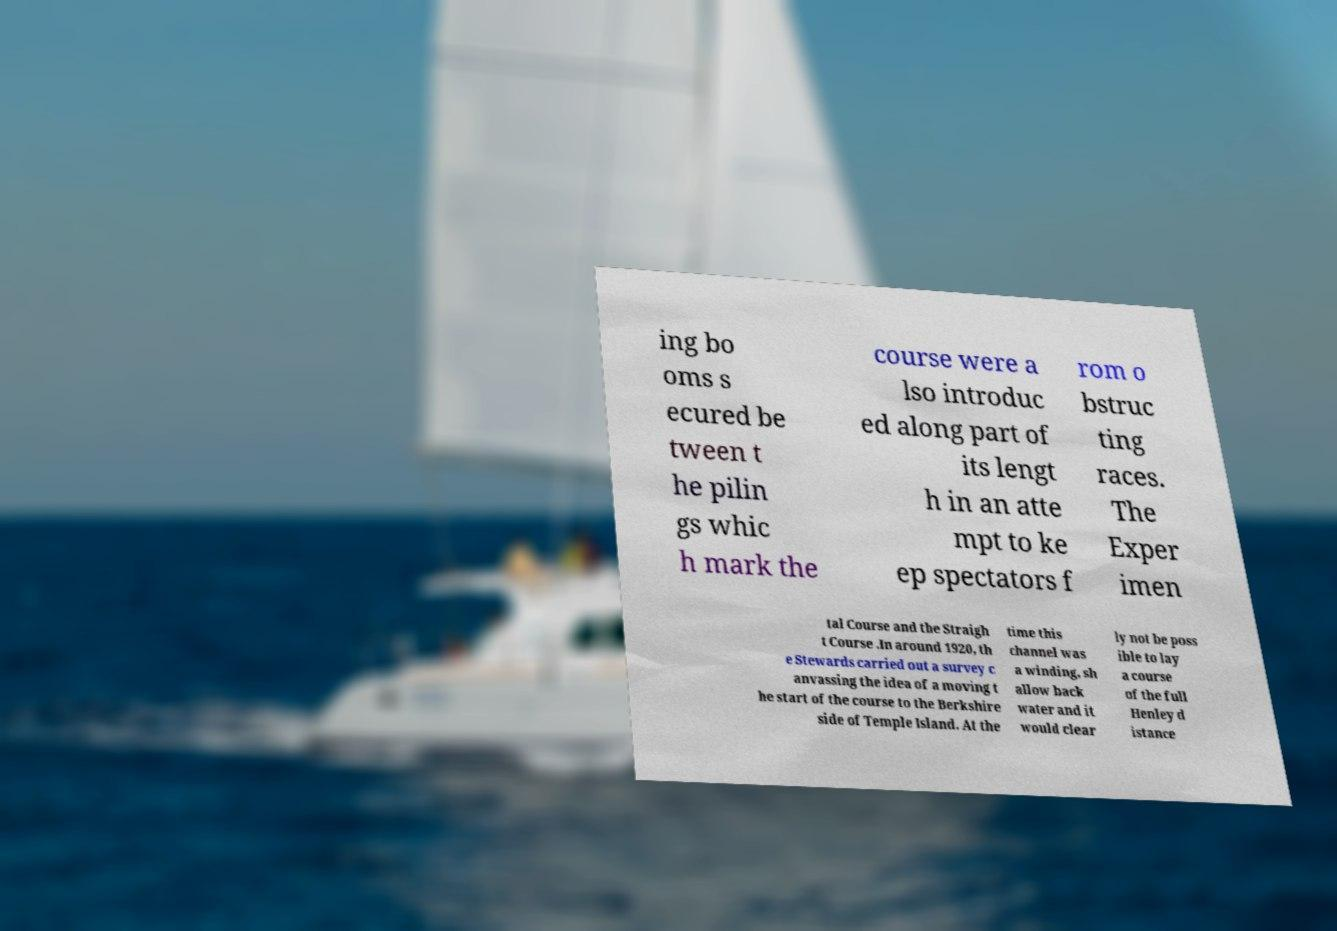I need the written content from this picture converted into text. Can you do that? ing bo oms s ecured be tween t he pilin gs whic h mark the course were a lso introduc ed along part of its lengt h in an atte mpt to ke ep spectators f rom o bstruc ting races. The Exper imen tal Course and the Straigh t Course .In around 1920, th e Stewards carried out a survey c anvassing the idea of a moving t he start of the course to the Berkshire side of Temple Island. At the time this channel was a winding, sh allow back water and it would clear ly not be poss ible to lay a course of the full Henley d istance 